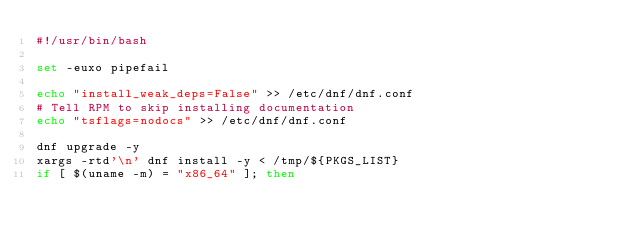<code> <loc_0><loc_0><loc_500><loc_500><_Bash_>#!/usr/bin/bash

set -euxo pipefail

echo "install_weak_deps=False" >> /etc/dnf/dnf.conf
# Tell RPM to skip installing documentation
echo "tsflags=nodocs" >> /etc/dnf/dnf.conf

dnf upgrade -y
xargs -rtd'\n' dnf install -y < /tmp/${PKGS_LIST}
if [ $(uname -m) = "x86_64" ]; then</code> 